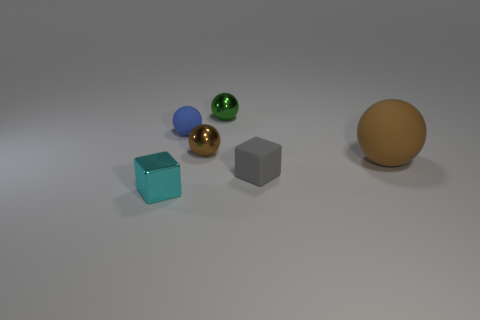Can you describe the positioning of the objects relative to each other? Certainly! The objects are laid out in a scattered formation on a flat surface, with no discernible pattern. They are placed at varying distances from each other, presenting a relaxed and random arrangement. 